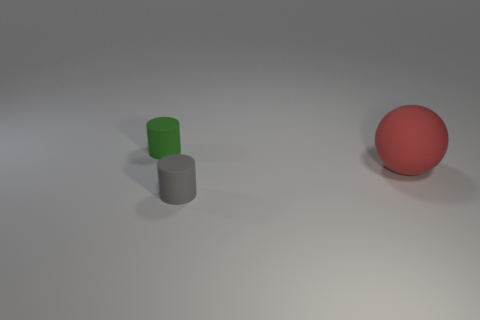Add 2 small purple rubber balls. How many objects exist? 5 Subtract all spheres. How many objects are left? 2 Add 2 matte balls. How many matte balls are left? 3 Add 3 things. How many things exist? 6 Subtract 0 blue cylinders. How many objects are left? 3 Subtract all green rubber things. Subtract all gray cylinders. How many objects are left? 1 